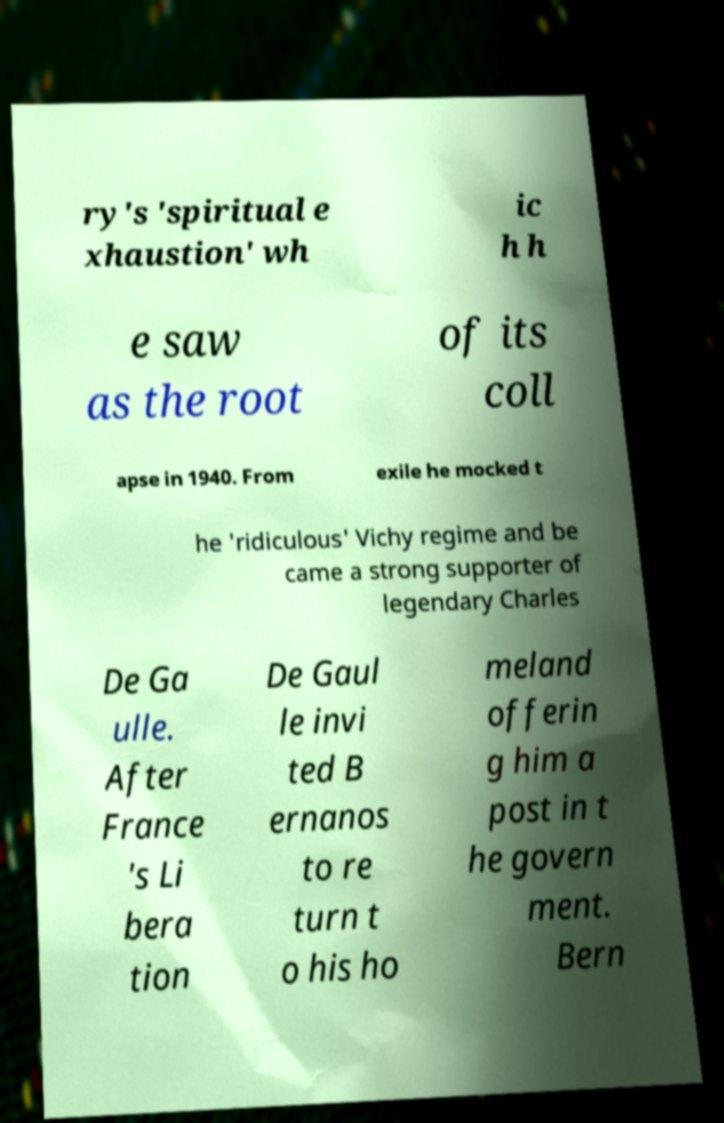For documentation purposes, I need the text within this image transcribed. Could you provide that? ry's 'spiritual e xhaustion' wh ic h h e saw as the root of its coll apse in 1940. From exile he mocked t he 'ridiculous' Vichy regime and be came a strong supporter of legendary Charles De Ga ulle. After France 's Li bera tion De Gaul le invi ted B ernanos to re turn t o his ho meland offerin g him a post in t he govern ment. Bern 